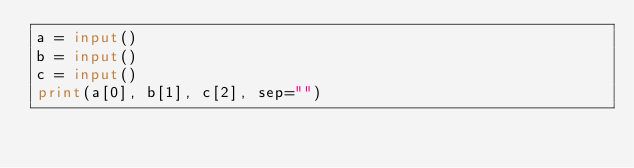Convert code to text. <code><loc_0><loc_0><loc_500><loc_500><_Python_>a = input()
b = input()
c = input()
print(a[0], b[1], c[2], sep="")</code> 